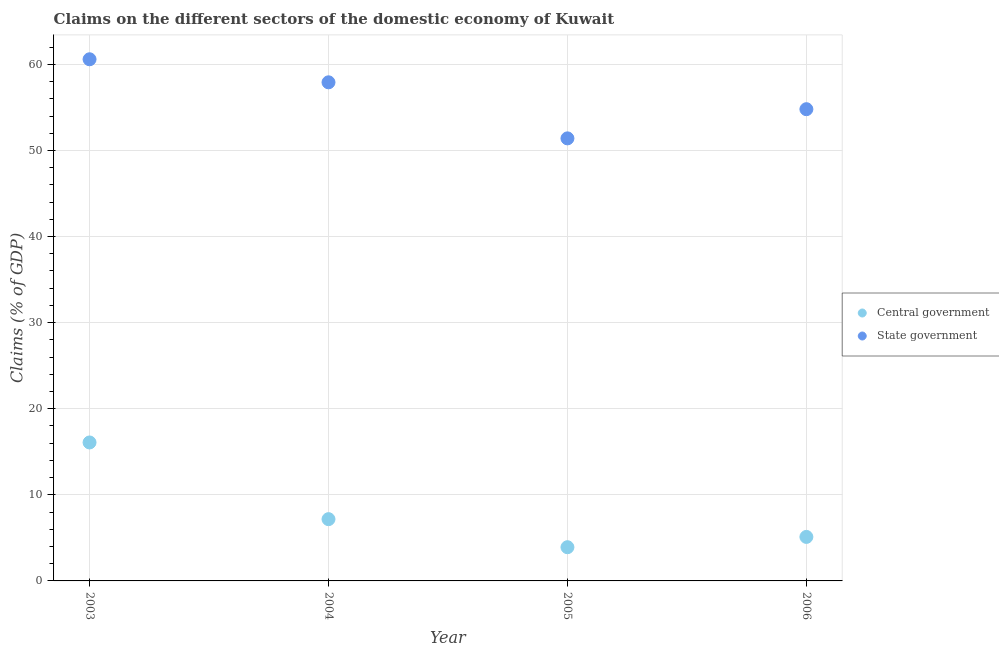How many different coloured dotlines are there?
Your answer should be very brief. 2. What is the claims on state government in 2006?
Offer a terse response. 54.8. Across all years, what is the maximum claims on state government?
Give a very brief answer. 60.59. Across all years, what is the minimum claims on central government?
Provide a short and direct response. 3.92. In which year was the claims on state government minimum?
Your response must be concise. 2005. What is the total claims on central government in the graph?
Your answer should be compact. 32.29. What is the difference between the claims on state government in 2003 and that in 2004?
Offer a terse response. 2.68. What is the difference between the claims on central government in 2005 and the claims on state government in 2004?
Offer a terse response. -54. What is the average claims on state government per year?
Keep it short and to the point. 56.18. In the year 2006, what is the difference between the claims on central government and claims on state government?
Offer a terse response. -49.68. What is the ratio of the claims on state government in 2003 to that in 2004?
Keep it short and to the point. 1.05. What is the difference between the highest and the second highest claims on state government?
Offer a terse response. 2.68. What is the difference between the highest and the lowest claims on state government?
Keep it short and to the point. 9.19. In how many years, is the claims on state government greater than the average claims on state government taken over all years?
Offer a very short reply. 2. Is the sum of the claims on central government in 2004 and 2006 greater than the maximum claims on state government across all years?
Make the answer very short. No. Does the claims on central government monotonically increase over the years?
Your answer should be very brief. No. Is the claims on central government strictly less than the claims on state government over the years?
Your answer should be compact. Yes. How many years are there in the graph?
Ensure brevity in your answer.  4. Does the graph contain grids?
Your answer should be very brief. Yes. Where does the legend appear in the graph?
Provide a short and direct response. Center right. How are the legend labels stacked?
Your answer should be very brief. Vertical. What is the title of the graph?
Your response must be concise. Claims on the different sectors of the domestic economy of Kuwait. What is the label or title of the X-axis?
Offer a terse response. Year. What is the label or title of the Y-axis?
Your answer should be compact. Claims (% of GDP). What is the Claims (% of GDP) of Central government in 2003?
Provide a succinct answer. 16.08. What is the Claims (% of GDP) of State government in 2003?
Offer a very short reply. 60.59. What is the Claims (% of GDP) of Central government in 2004?
Offer a terse response. 7.17. What is the Claims (% of GDP) of State government in 2004?
Keep it short and to the point. 57.92. What is the Claims (% of GDP) of Central government in 2005?
Your answer should be very brief. 3.92. What is the Claims (% of GDP) of State government in 2005?
Make the answer very short. 51.41. What is the Claims (% of GDP) in Central government in 2006?
Offer a terse response. 5.11. What is the Claims (% of GDP) in State government in 2006?
Your answer should be compact. 54.8. Across all years, what is the maximum Claims (% of GDP) of Central government?
Provide a short and direct response. 16.08. Across all years, what is the maximum Claims (% of GDP) in State government?
Your response must be concise. 60.59. Across all years, what is the minimum Claims (% of GDP) in Central government?
Provide a succinct answer. 3.92. Across all years, what is the minimum Claims (% of GDP) in State government?
Give a very brief answer. 51.41. What is the total Claims (% of GDP) of Central government in the graph?
Offer a very short reply. 32.29. What is the total Claims (% of GDP) in State government in the graph?
Your response must be concise. 224.71. What is the difference between the Claims (% of GDP) of Central government in 2003 and that in 2004?
Ensure brevity in your answer.  8.91. What is the difference between the Claims (% of GDP) in State government in 2003 and that in 2004?
Provide a short and direct response. 2.68. What is the difference between the Claims (% of GDP) in Central government in 2003 and that in 2005?
Make the answer very short. 12.17. What is the difference between the Claims (% of GDP) in State government in 2003 and that in 2005?
Offer a very short reply. 9.19. What is the difference between the Claims (% of GDP) of Central government in 2003 and that in 2006?
Keep it short and to the point. 10.97. What is the difference between the Claims (% of GDP) in State government in 2003 and that in 2006?
Keep it short and to the point. 5.8. What is the difference between the Claims (% of GDP) in Central government in 2004 and that in 2005?
Provide a short and direct response. 3.26. What is the difference between the Claims (% of GDP) of State government in 2004 and that in 2005?
Offer a very short reply. 6.51. What is the difference between the Claims (% of GDP) of Central government in 2004 and that in 2006?
Offer a very short reply. 2.06. What is the difference between the Claims (% of GDP) of State government in 2004 and that in 2006?
Keep it short and to the point. 3.12. What is the difference between the Claims (% of GDP) in Central government in 2005 and that in 2006?
Give a very brief answer. -1.2. What is the difference between the Claims (% of GDP) of State government in 2005 and that in 2006?
Provide a succinct answer. -3.39. What is the difference between the Claims (% of GDP) in Central government in 2003 and the Claims (% of GDP) in State government in 2004?
Make the answer very short. -41.83. What is the difference between the Claims (% of GDP) of Central government in 2003 and the Claims (% of GDP) of State government in 2005?
Offer a terse response. -35.32. What is the difference between the Claims (% of GDP) in Central government in 2003 and the Claims (% of GDP) in State government in 2006?
Provide a short and direct response. -38.71. What is the difference between the Claims (% of GDP) in Central government in 2004 and the Claims (% of GDP) in State government in 2005?
Offer a very short reply. -44.23. What is the difference between the Claims (% of GDP) in Central government in 2004 and the Claims (% of GDP) in State government in 2006?
Provide a succinct answer. -47.62. What is the difference between the Claims (% of GDP) of Central government in 2005 and the Claims (% of GDP) of State government in 2006?
Provide a succinct answer. -50.88. What is the average Claims (% of GDP) of Central government per year?
Offer a very short reply. 8.07. What is the average Claims (% of GDP) in State government per year?
Your response must be concise. 56.18. In the year 2003, what is the difference between the Claims (% of GDP) in Central government and Claims (% of GDP) in State government?
Offer a terse response. -44.51. In the year 2004, what is the difference between the Claims (% of GDP) of Central government and Claims (% of GDP) of State government?
Make the answer very short. -50.74. In the year 2005, what is the difference between the Claims (% of GDP) in Central government and Claims (% of GDP) in State government?
Give a very brief answer. -47.49. In the year 2006, what is the difference between the Claims (% of GDP) of Central government and Claims (% of GDP) of State government?
Offer a very short reply. -49.68. What is the ratio of the Claims (% of GDP) of Central government in 2003 to that in 2004?
Your answer should be very brief. 2.24. What is the ratio of the Claims (% of GDP) in State government in 2003 to that in 2004?
Offer a terse response. 1.05. What is the ratio of the Claims (% of GDP) in Central government in 2003 to that in 2005?
Your response must be concise. 4.11. What is the ratio of the Claims (% of GDP) in State government in 2003 to that in 2005?
Offer a terse response. 1.18. What is the ratio of the Claims (% of GDP) in Central government in 2003 to that in 2006?
Your response must be concise. 3.15. What is the ratio of the Claims (% of GDP) in State government in 2003 to that in 2006?
Your response must be concise. 1.11. What is the ratio of the Claims (% of GDP) of Central government in 2004 to that in 2005?
Provide a short and direct response. 1.83. What is the ratio of the Claims (% of GDP) of State government in 2004 to that in 2005?
Ensure brevity in your answer.  1.13. What is the ratio of the Claims (% of GDP) of Central government in 2004 to that in 2006?
Give a very brief answer. 1.4. What is the ratio of the Claims (% of GDP) in State government in 2004 to that in 2006?
Make the answer very short. 1.06. What is the ratio of the Claims (% of GDP) in Central government in 2005 to that in 2006?
Your response must be concise. 0.77. What is the ratio of the Claims (% of GDP) in State government in 2005 to that in 2006?
Ensure brevity in your answer.  0.94. What is the difference between the highest and the second highest Claims (% of GDP) in Central government?
Ensure brevity in your answer.  8.91. What is the difference between the highest and the second highest Claims (% of GDP) in State government?
Ensure brevity in your answer.  2.68. What is the difference between the highest and the lowest Claims (% of GDP) in Central government?
Give a very brief answer. 12.17. What is the difference between the highest and the lowest Claims (% of GDP) in State government?
Offer a very short reply. 9.19. 